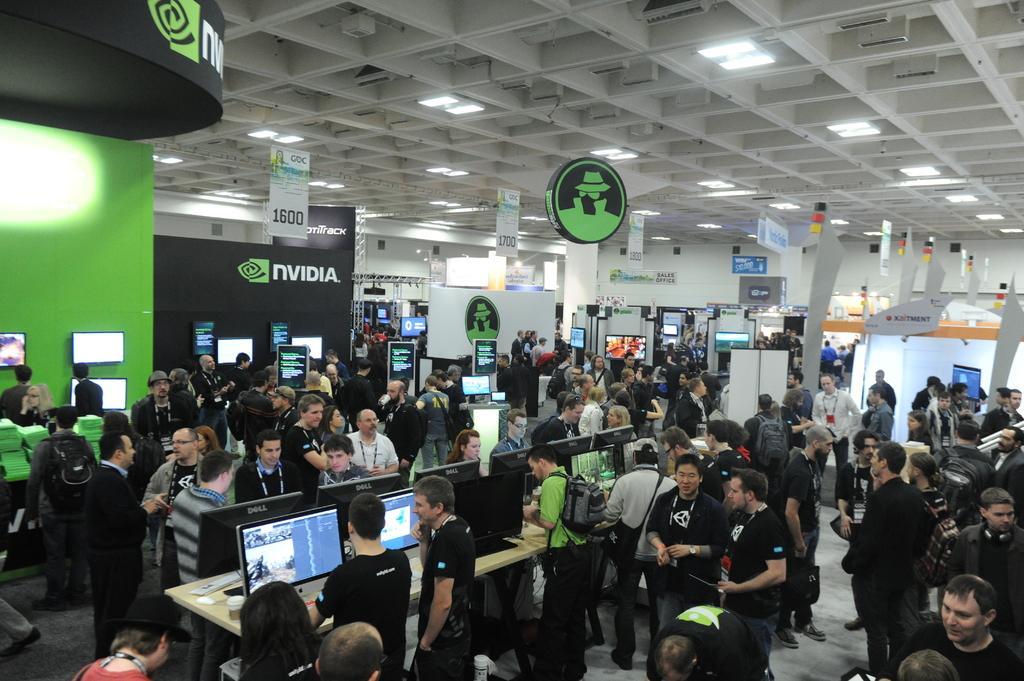In one or two sentences, can you explain what this image depicts? In this image we can see a group of persons. In front of the persons we can see the monitors on the tables and the walls. On the walls we can see the text. At the top we can see the roof, lights and posters. 